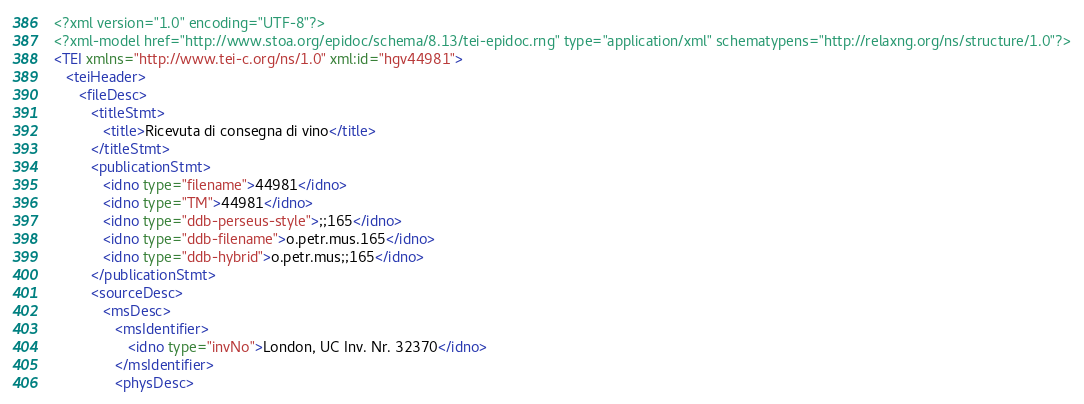Convert code to text. <code><loc_0><loc_0><loc_500><loc_500><_XML_><?xml version="1.0" encoding="UTF-8"?>
<?xml-model href="http://www.stoa.org/epidoc/schema/8.13/tei-epidoc.rng" type="application/xml" schematypens="http://relaxng.org/ns/structure/1.0"?>
<TEI xmlns="http://www.tei-c.org/ns/1.0" xml:id="hgv44981">
   <teiHeader>
      <fileDesc>
         <titleStmt>
            <title>Ricevuta di consegna di vino</title>
         </titleStmt>
         <publicationStmt>
            <idno type="filename">44981</idno>
            <idno type="TM">44981</idno>
            <idno type="ddb-perseus-style">;;165</idno>
            <idno type="ddb-filename">o.petr.mus.165</idno>
            <idno type="ddb-hybrid">o.petr.mus;;165</idno>
         </publicationStmt>
         <sourceDesc>
            <msDesc>
               <msIdentifier>
                  <idno type="invNo">London, UC Inv. Nr. 32370</idno>
               </msIdentifier>
               <physDesc></code> 